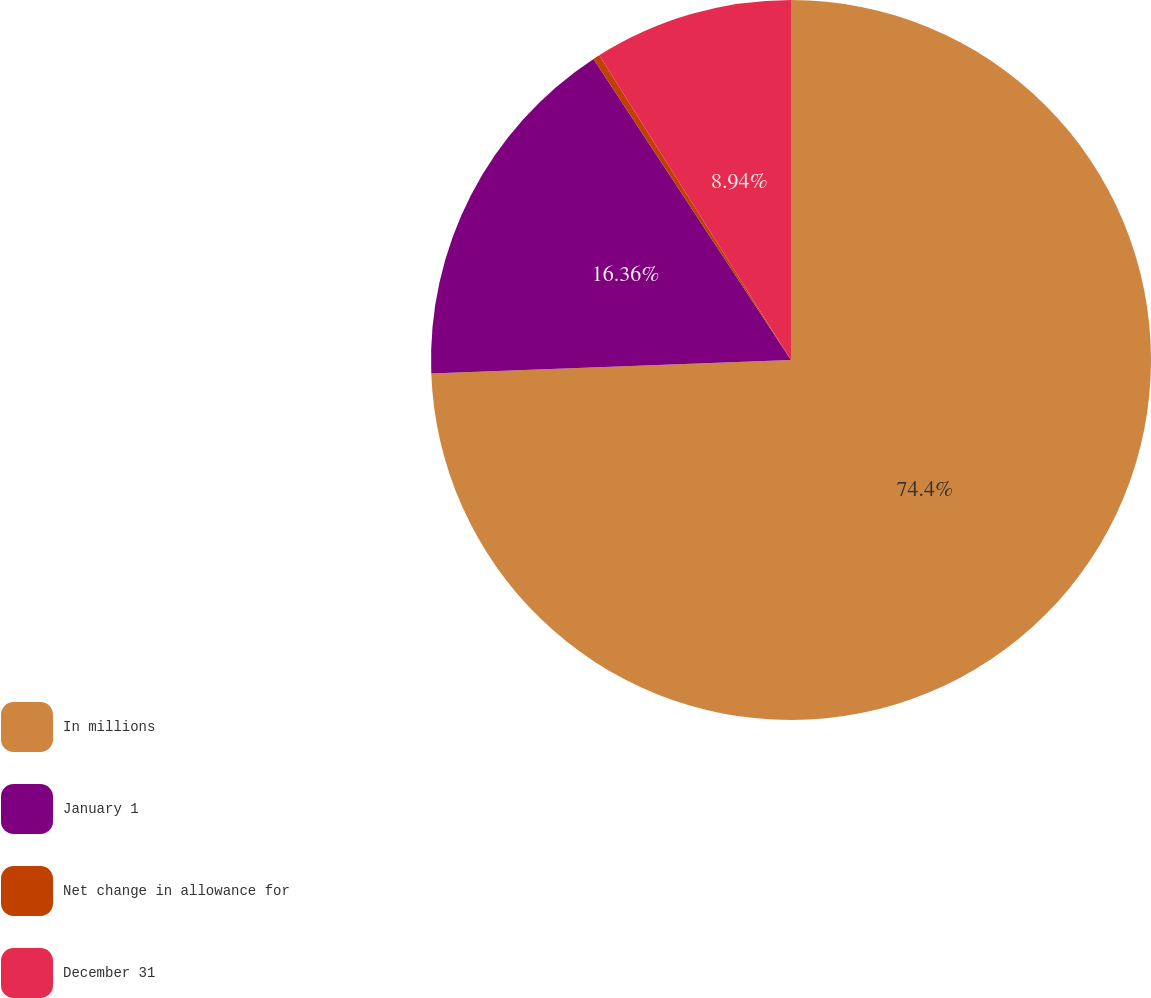Convert chart to OTSL. <chart><loc_0><loc_0><loc_500><loc_500><pie_chart><fcel>In millions<fcel>January 1<fcel>Net change in allowance for<fcel>December 31<nl><fcel>74.4%<fcel>16.36%<fcel>0.3%<fcel>8.94%<nl></chart> 